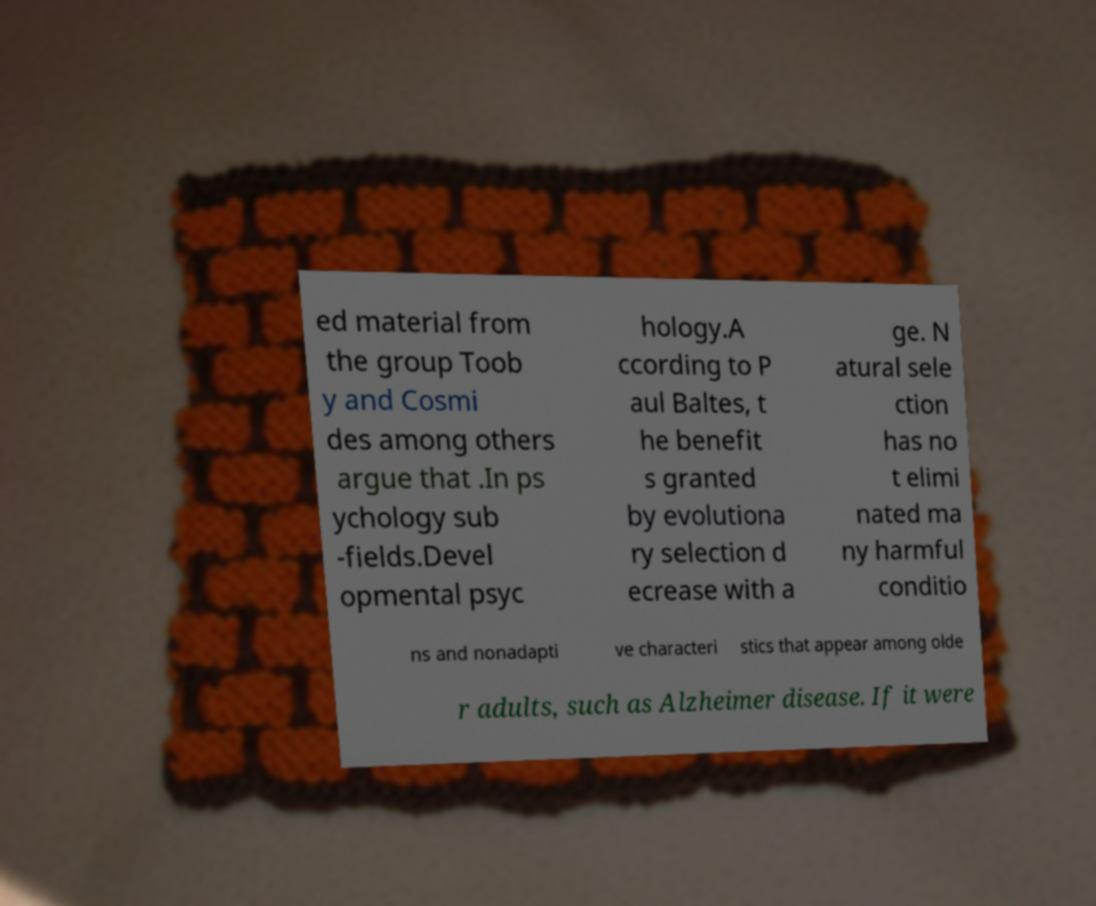Can you accurately transcribe the text from the provided image for me? ed material from the group Toob y and Cosmi des among others argue that .In ps ychology sub -fields.Devel opmental psyc hology.A ccording to P aul Baltes, t he benefit s granted by evolutiona ry selection d ecrease with a ge. N atural sele ction has no t elimi nated ma ny harmful conditio ns and nonadapti ve characteri stics that appear among olde r adults, such as Alzheimer disease. If it were 